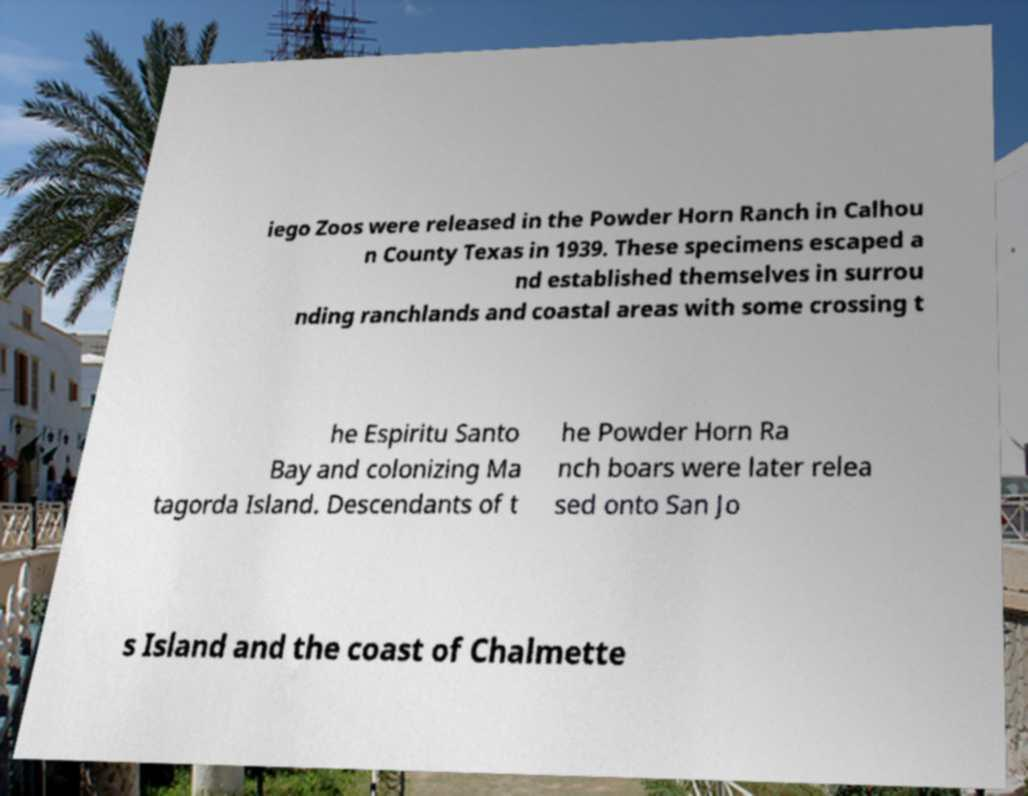Could you extract and type out the text from this image? iego Zoos were released in the Powder Horn Ranch in Calhou n County Texas in 1939. These specimens escaped a nd established themselves in surrou nding ranchlands and coastal areas with some crossing t he Espiritu Santo Bay and colonizing Ma tagorda Island. Descendants of t he Powder Horn Ra nch boars were later relea sed onto San Jo s Island and the coast of Chalmette 